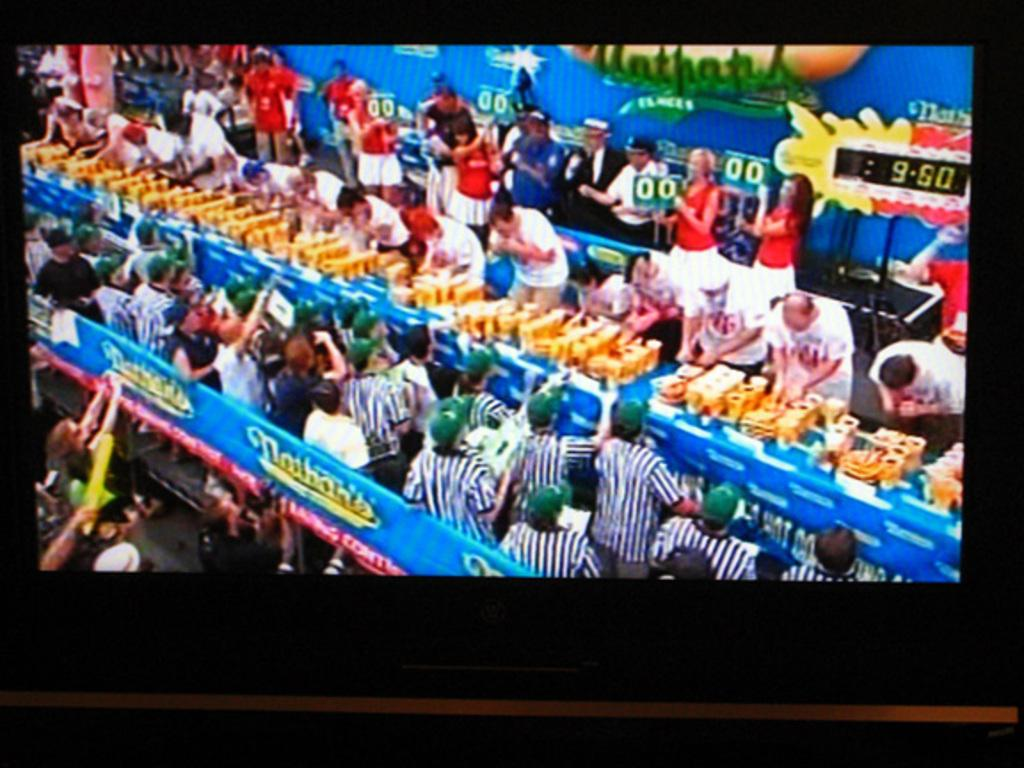<image>
Describe the image concisely. the time is 9:50 on the screen behind people 